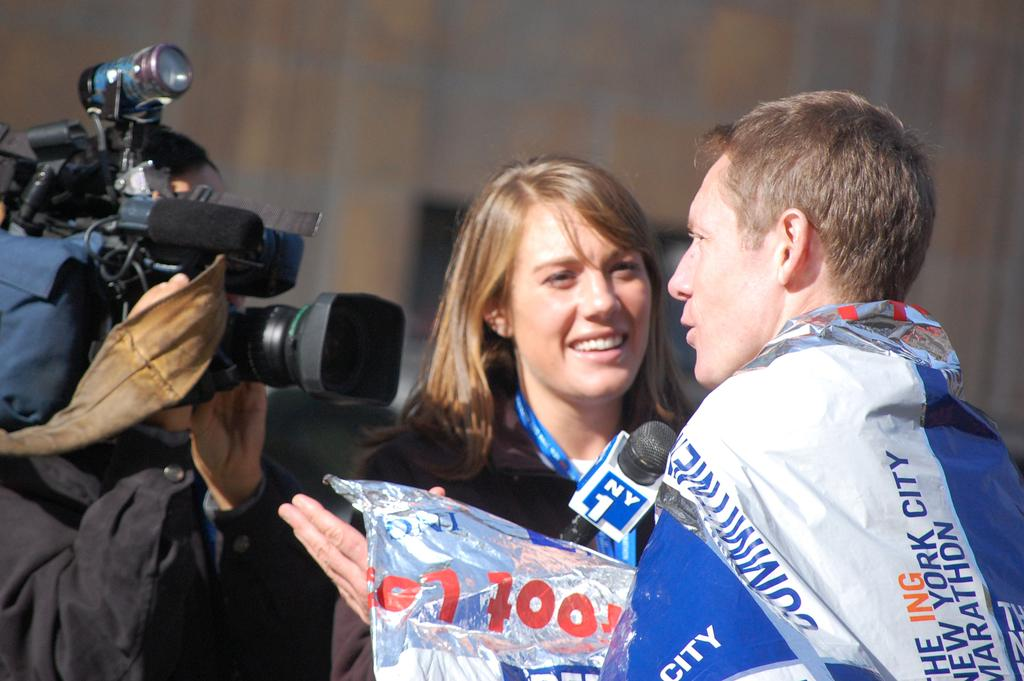Who are the people in the image? There is a woman and a man in the image. What is the woman holding in the image? The woman is holding a microphone. Can you describe the person holding a camera in the image? There is a person holding a camera in the image. What type of throat medicine is the woman taking in the image? There is no indication in the image that the woman is taking any throat medicine. 